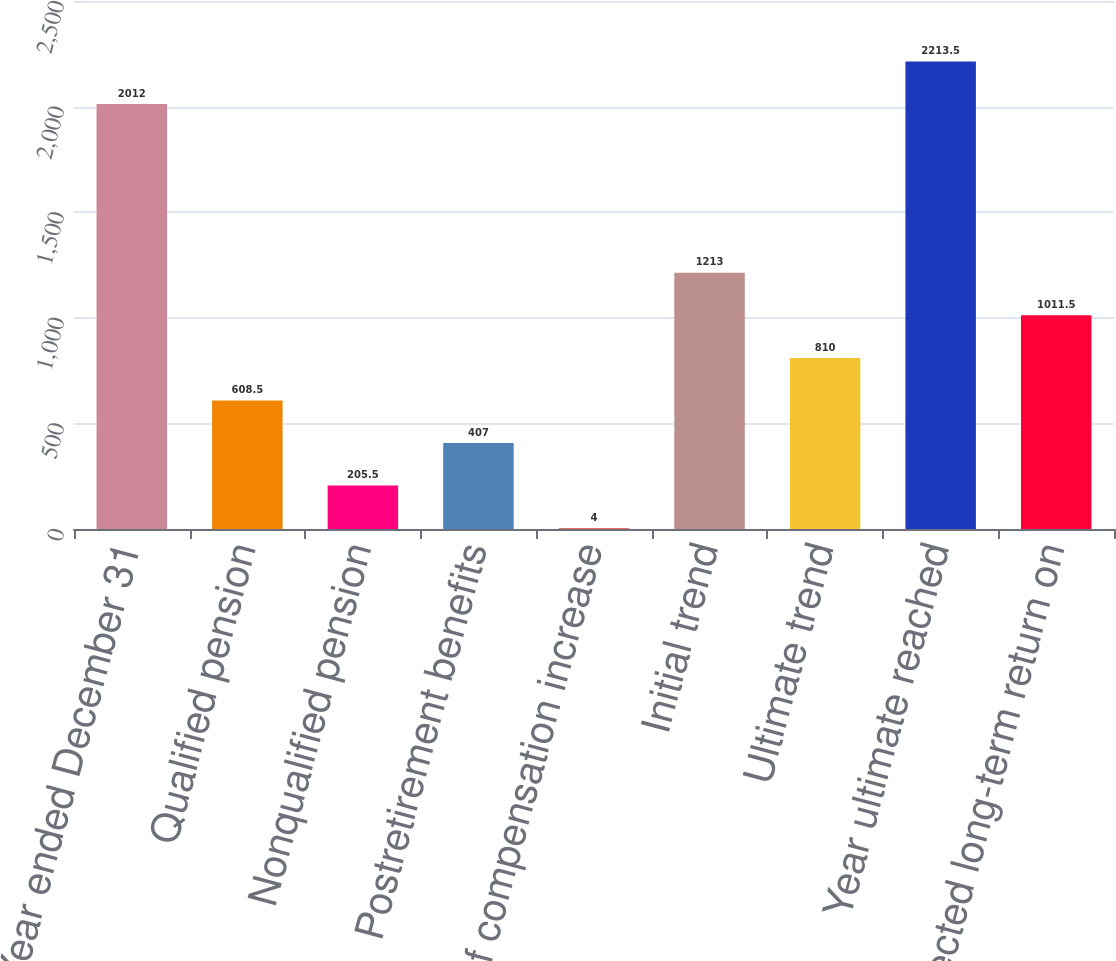Convert chart. <chart><loc_0><loc_0><loc_500><loc_500><bar_chart><fcel>Year ended December 31<fcel>Qualified pension<fcel>Nonqualified pension<fcel>Postretirement benefits<fcel>Rate of compensation increase<fcel>Initial trend<fcel>Ultimate trend<fcel>Year ultimate reached<fcel>Expected long-term return on<nl><fcel>2012<fcel>608.5<fcel>205.5<fcel>407<fcel>4<fcel>1213<fcel>810<fcel>2213.5<fcel>1011.5<nl></chart> 